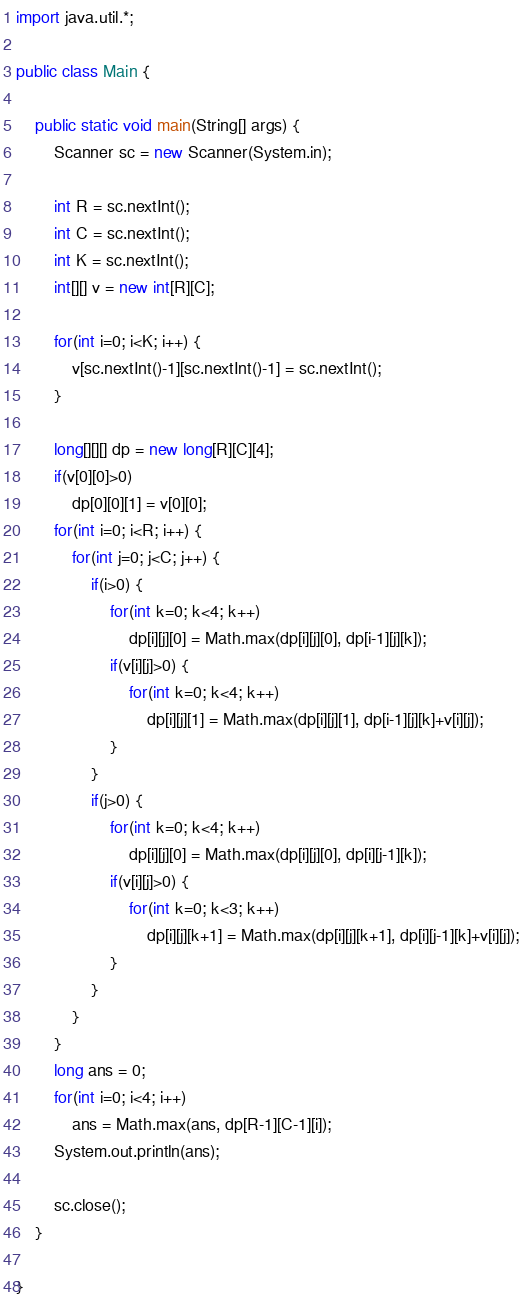<code> <loc_0><loc_0><loc_500><loc_500><_Java_>import java.util.*;

public class Main {
	
	public static void main(String[] args) {
		Scanner sc = new Scanner(System.in);
		
		int R = sc.nextInt();
		int C = sc.nextInt();
		int K = sc.nextInt();
		int[][] v = new int[R][C];
		
		for(int i=0; i<K; i++) {
			v[sc.nextInt()-1][sc.nextInt()-1] = sc.nextInt();
		}

		long[][][] dp = new long[R][C][4];
		if(v[0][0]>0)
			dp[0][0][1] = v[0][0];
		for(int i=0; i<R; i++) {
			for(int j=0; j<C; j++) {
				if(i>0) {
					for(int k=0; k<4; k++)
						dp[i][j][0] = Math.max(dp[i][j][0], dp[i-1][j][k]);
					if(v[i][j]>0) {
						for(int k=0; k<4; k++)
							dp[i][j][1] = Math.max(dp[i][j][1], dp[i-1][j][k]+v[i][j]);
					}
				}
				if(j>0) {
					for(int k=0; k<4; k++)
						dp[i][j][0] = Math.max(dp[i][j][0], dp[i][j-1][k]);
					if(v[i][j]>0) {
						for(int k=0; k<3; k++)
							dp[i][j][k+1] = Math.max(dp[i][j][k+1], dp[i][j-1][k]+v[i][j]);
					}
				}
			}
		}
		long ans = 0;
		for(int i=0; i<4; i++)
			ans = Math.max(ans, dp[R-1][C-1][i]);
		System.out.println(ans);
		
		sc.close();
	}
	
}

</code> 